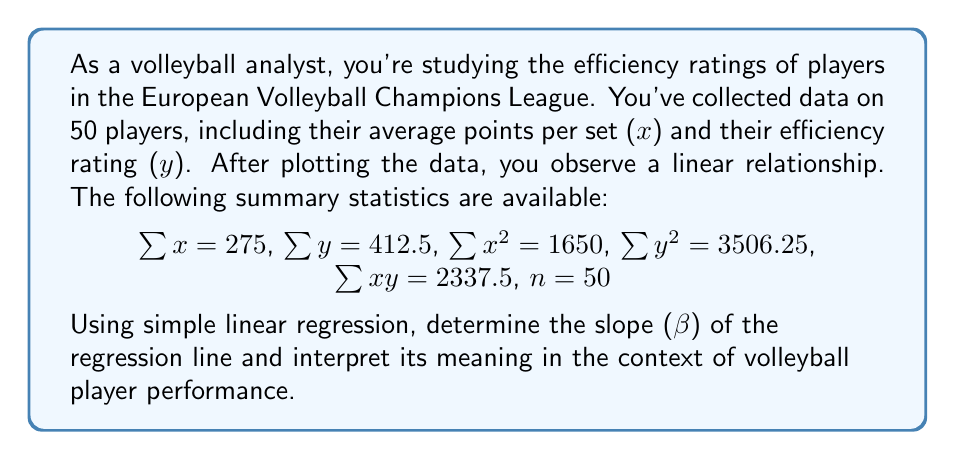Give your solution to this math problem. To find the slope of the regression line, we'll use the formula:

$$ \beta = \frac{n\sum xy - \sum x \sum y}{n\sum x^2 - (\sum x)^2} $$

Let's substitute the given values:

$$ \beta = \frac{50(2337.5) - 275(412.5)}{50(1650) - 275^2} $$

$$ \beta = \frac{116875 - 113437.5}{82500 - 75625} $$

$$ \beta = \frac{3437.5}{6875} $$

$$ \beta = 0.5 $$

Interpretation:
The slope (β) of 0.5 indicates that for every 1-point increase in a player's average points per set, their efficiency rating is expected to increase by 0.5 units. This positive relationship suggests that players who score more points per set tend to have higher efficiency ratings.

In the context of volleyball:
1. This relationship helps coaches and analysts understand how scoring ability translates to overall efficiency.
2. It can be used to predict a player's efficiency rating based on their scoring performance.
3. The moderate slope (0.5) implies that while scoring is important, other factors also contribute to a player's efficiency rating (e.g., serving, blocking, or defensive skills).
Answer: The slope (β) of the regression line is 0.5, indicating that for each 1-point increase in average points per set, a player's efficiency rating is expected to increase by 0.5 units. 